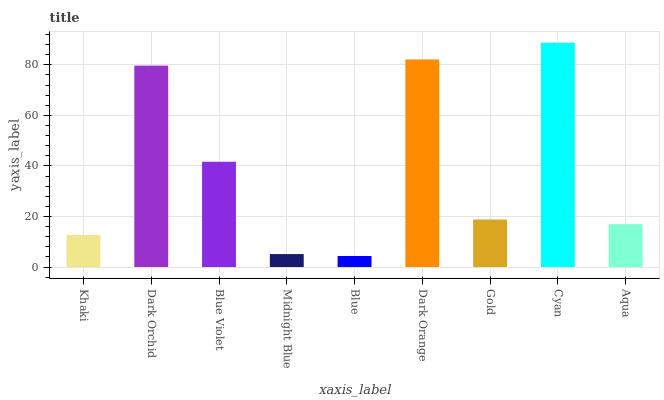Is Dark Orchid the minimum?
Answer yes or no. No. Is Dark Orchid the maximum?
Answer yes or no. No. Is Dark Orchid greater than Khaki?
Answer yes or no. Yes. Is Khaki less than Dark Orchid?
Answer yes or no. Yes. Is Khaki greater than Dark Orchid?
Answer yes or no. No. Is Dark Orchid less than Khaki?
Answer yes or no. No. Is Gold the high median?
Answer yes or no. Yes. Is Gold the low median?
Answer yes or no. Yes. Is Blue the high median?
Answer yes or no. No. Is Blue the low median?
Answer yes or no. No. 